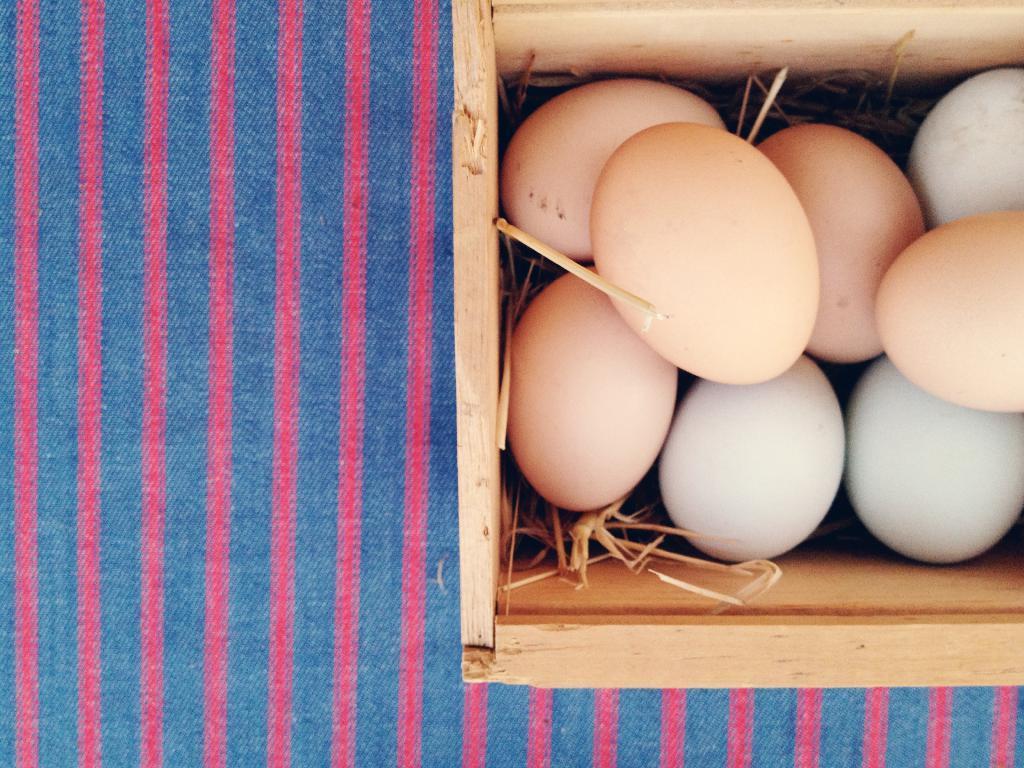Please provide a concise description of this image. In this picture there is a wooden box which has few eggs placed in it and there is grass under the eggs and there is a cloth under the wooden box. 